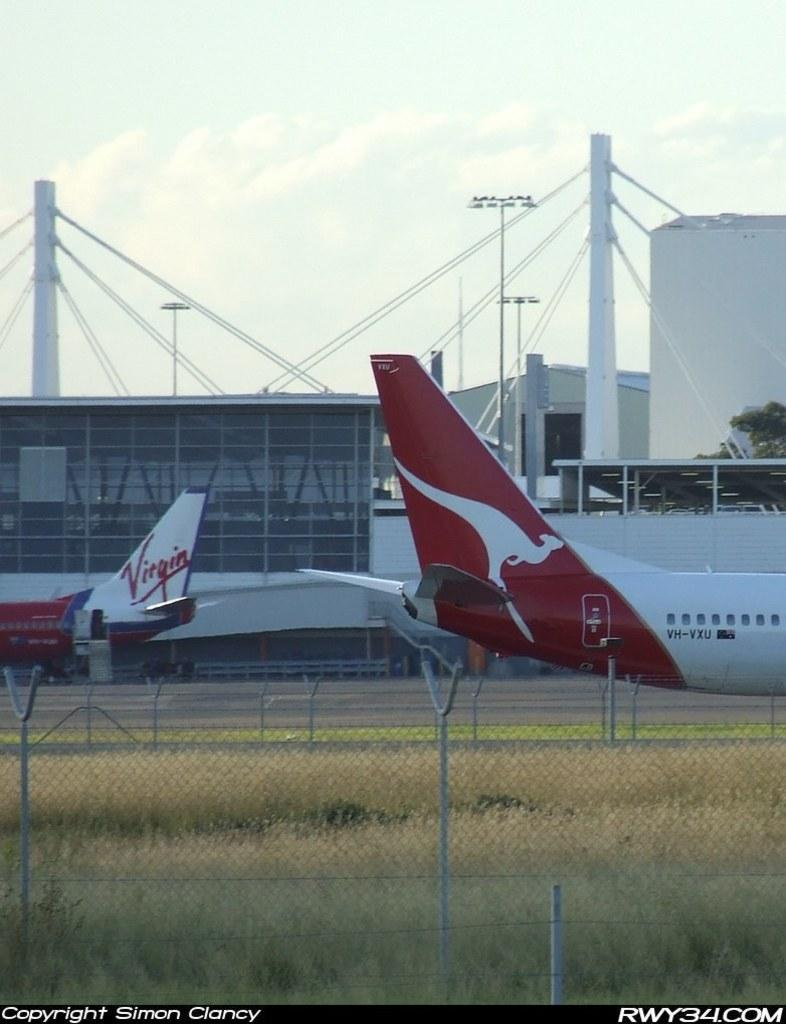<image>
Create a compact narrative representing the image presented. Two planes one has a kangaroo on it and the other from Virgin airlines. 